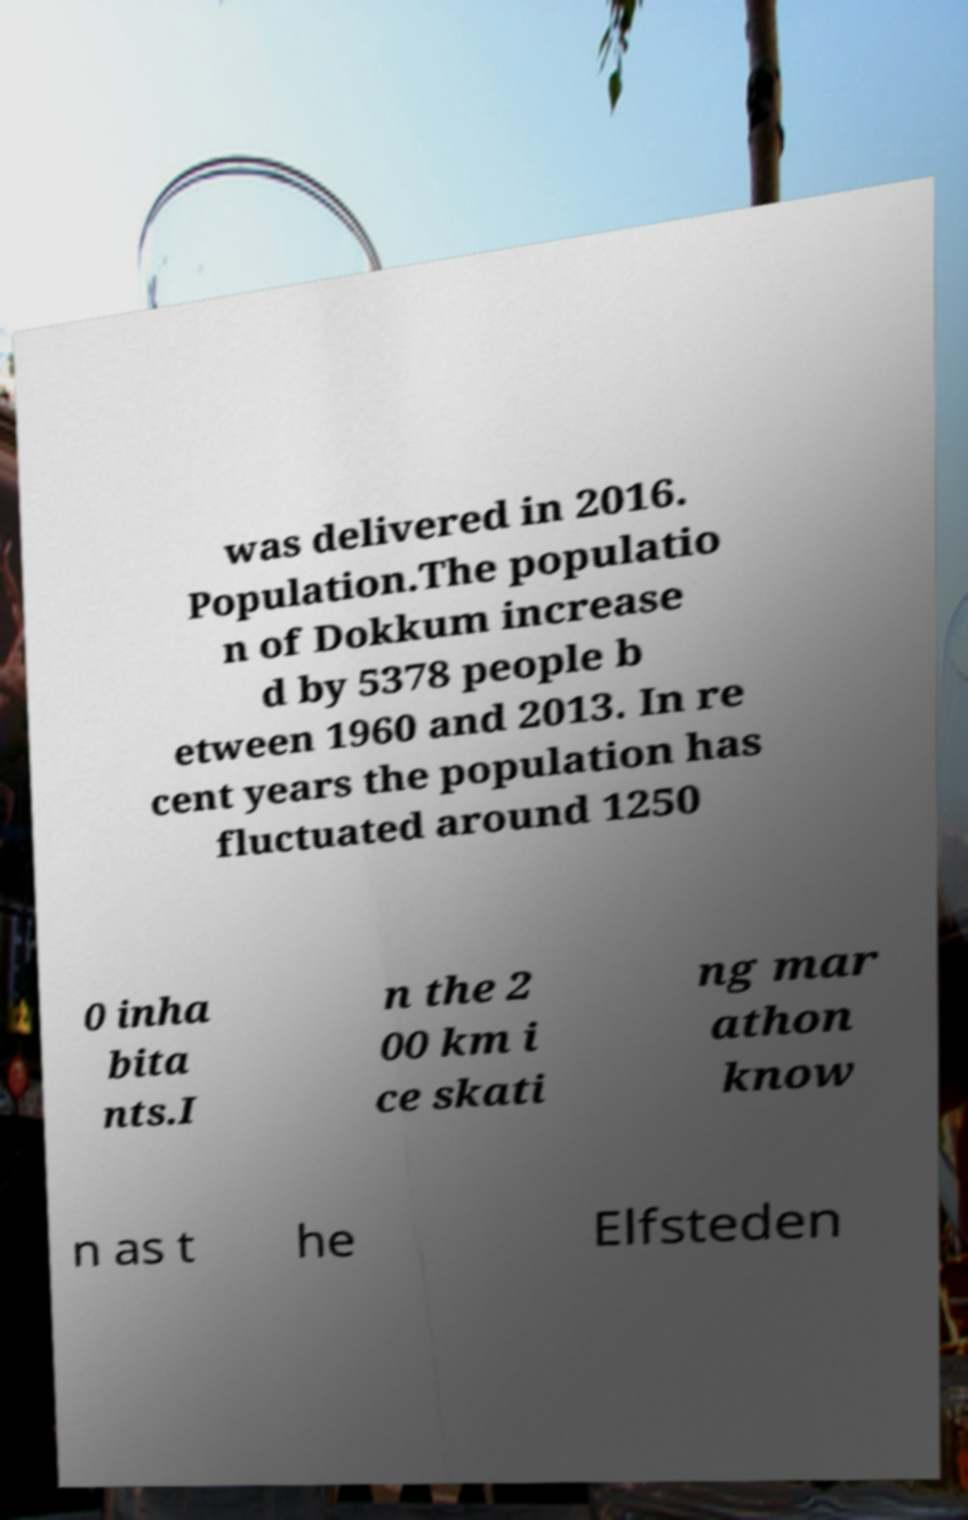Can you accurately transcribe the text from the provided image for me? was delivered in 2016. Population.The populatio n of Dokkum increase d by 5378 people b etween 1960 and 2013. In re cent years the population has fluctuated around 1250 0 inha bita nts.I n the 2 00 km i ce skati ng mar athon know n as t he Elfsteden 